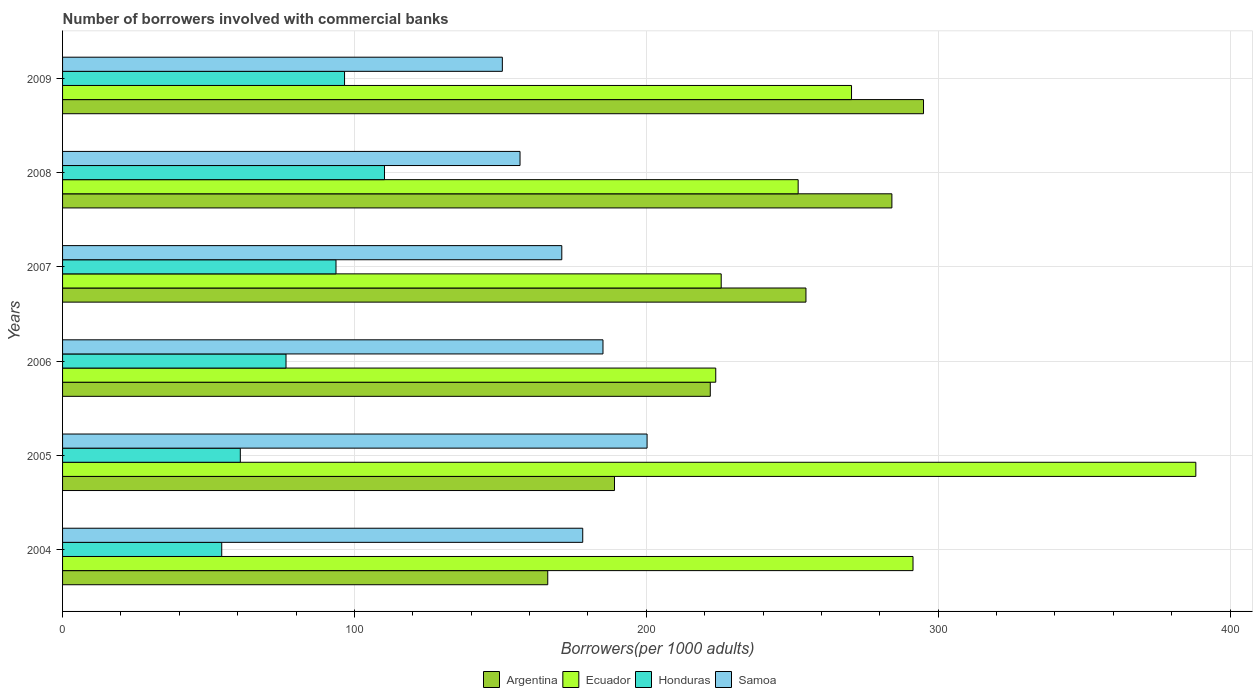Are the number of bars on each tick of the Y-axis equal?
Ensure brevity in your answer.  Yes. How many bars are there on the 5th tick from the top?
Your response must be concise. 4. How many bars are there on the 2nd tick from the bottom?
Keep it short and to the point. 4. In how many cases, is the number of bars for a given year not equal to the number of legend labels?
Offer a very short reply. 0. What is the number of borrowers involved with commercial banks in Honduras in 2006?
Give a very brief answer. 76.56. Across all years, what is the maximum number of borrowers involved with commercial banks in Ecuador?
Ensure brevity in your answer.  388.27. Across all years, what is the minimum number of borrowers involved with commercial banks in Ecuador?
Your answer should be compact. 223.79. In which year was the number of borrowers involved with commercial banks in Argentina minimum?
Ensure brevity in your answer.  2004. What is the total number of borrowers involved with commercial banks in Ecuador in the graph?
Your answer should be very brief. 1651.41. What is the difference between the number of borrowers involved with commercial banks in Honduras in 2004 and that in 2009?
Your answer should be compact. -42.07. What is the difference between the number of borrowers involved with commercial banks in Samoa in 2006 and the number of borrowers involved with commercial banks in Honduras in 2009?
Keep it short and to the point. 88.55. What is the average number of borrowers involved with commercial banks in Samoa per year?
Make the answer very short. 173.68. In the year 2005, what is the difference between the number of borrowers involved with commercial banks in Samoa and number of borrowers involved with commercial banks in Ecuador?
Make the answer very short. -188.01. In how many years, is the number of borrowers involved with commercial banks in Samoa greater than 200 ?
Offer a very short reply. 1. What is the ratio of the number of borrowers involved with commercial banks in Samoa in 2004 to that in 2009?
Your response must be concise. 1.18. What is the difference between the highest and the second highest number of borrowers involved with commercial banks in Samoa?
Your answer should be compact. 15.11. What is the difference between the highest and the lowest number of borrowers involved with commercial banks in Honduras?
Your answer should be very brief. 55.76. Is it the case that in every year, the sum of the number of borrowers involved with commercial banks in Honduras and number of borrowers involved with commercial banks in Ecuador is greater than the sum of number of borrowers involved with commercial banks in Samoa and number of borrowers involved with commercial banks in Argentina?
Provide a short and direct response. No. What does the 4th bar from the bottom in 2005 represents?
Offer a terse response. Samoa. Is it the case that in every year, the sum of the number of borrowers involved with commercial banks in Argentina and number of borrowers involved with commercial banks in Ecuador is greater than the number of borrowers involved with commercial banks in Samoa?
Give a very brief answer. Yes. How many bars are there?
Your answer should be compact. 24. Are all the bars in the graph horizontal?
Offer a terse response. Yes. How many years are there in the graph?
Your answer should be very brief. 6. What is the difference between two consecutive major ticks on the X-axis?
Your answer should be compact. 100. Does the graph contain grids?
Keep it short and to the point. Yes. How many legend labels are there?
Make the answer very short. 4. What is the title of the graph?
Provide a succinct answer. Number of borrowers involved with commercial banks. Does "Slovenia" appear as one of the legend labels in the graph?
Keep it short and to the point. No. What is the label or title of the X-axis?
Provide a succinct answer. Borrowers(per 1000 adults). What is the label or title of the Y-axis?
Offer a very short reply. Years. What is the Borrowers(per 1000 adults) in Argentina in 2004?
Provide a succinct answer. 166.23. What is the Borrowers(per 1000 adults) of Ecuador in 2004?
Your answer should be very brief. 291.37. What is the Borrowers(per 1000 adults) in Honduras in 2004?
Offer a terse response. 54.53. What is the Borrowers(per 1000 adults) of Samoa in 2004?
Give a very brief answer. 178.22. What is the Borrowers(per 1000 adults) of Argentina in 2005?
Ensure brevity in your answer.  189.09. What is the Borrowers(per 1000 adults) of Ecuador in 2005?
Offer a very short reply. 388.27. What is the Borrowers(per 1000 adults) in Honduras in 2005?
Your response must be concise. 60.9. What is the Borrowers(per 1000 adults) of Samoa in 2005?
Offer a very short reply. 200.26. What is the Borrowers(per 1000 adults) in Argentina in 2006?
Your response must be concise. 221.91. What is the Borrowers(per 1000 adults) in Ecuador in 2006?
Make the answer very short. 223.79. What is the Borrowers(per 1000 adults) in Honduras in 2006?
Your response must be concise. 76.56. What is the Borrowers(per 1000 adults) of Samoa in 2006?
Ensure brevity in your answer.  185.16. What is the Borrowers(per 1000 adults) of Argentina in 2007?
Your answer should be very brief. 254.69. What is the Borrowers(per 1000 adults) of Ecuador in 2007?
Make the answer very short. 225.65. What is the Borrowers(per 1000 adults) in Honduras in 2007?
Provide a succinct answer. 93.68. What is the Borrowers(per 1000 adults) in Samoa in 2007?
Ensure brevity in your answer.  171.04. What is the Borrowers(per 1000 adults) of Argentina in 2008?
Your response must be concise. 284.14. What is the Borrowers(per 1000 adults) in Ecuador in 2008?
Offer a terse response. 252.02. What is the Borrowers(per 1000 adults) in Honduras in 2008?
Provide a succinct answer. 110.29. What is the Borrowers(per 1000 adults) in Samoa in 2008?
Keep it short and to the point. 156.73. What is the Borrowers(per 1000 adults) in Argentina in 2009?
Provide a short and direct response. 294.97. What is the Borrowers(per 1000 adults) in Ecuador in 2009?
Keep it short and to the point. 270.31. What is the Borrowers(per 1000 adults) in Honduras in 2009?
Your answer should be compact. 96.61. What is the Borrowers(per 1000 adults) in Samoa in 2009?
Give a very brief answer. 150.68. Across all years, what is the maximum Borrowers(per 1000 adults) of Argentina?
Keep it short and to the point. 294.97. Across all years, what is the maximum Borrowers(per 1000 adults) of Ecuador?
Ensure brevity in your answer.  388.27. Across all years, what is the maximum Borrowers(per 1000 adults) of Honduras?
Provide a short and direct response. 110.29. Across all years, what is the maximum Borrowers(per 1000 adults) of Samoa?
Give a very brief answer. 200.26. Across all years, what is the minimum Borrowers(per 1000 adults) of Argentina?
Keep it short and to the point. 166.23. Across all years, what is the minimum Borrowers(per 1000 adults) in Ecuador?
Offer a very short reply. 223.79. Across all years, what is the minimum Borrowers(per 1000 adults) in Honduras?
Provide a short and direct response. 54.53. Across all years, what is the minimum Borrowers(per 1000 adults) of Samoa?
Keep it short and to the point. 150.68. What is the total Borrowers(per 1000 adults) of Argentina in the graph?
Keep it short and to the point. 1411.03. What is the total Borrowers(per 1000 adults) of Ecuador in the graph?
Give a very brief answer. 1651.41. What is the total Borrowers(per 1000 adults) in Honduras in the graph?
Your answer should be compact. 492.57. What is the total Borrowers(per 1000 adults) of Samoa in the graph?
Offer a terse response. 1042.09. What is the difference between the Borrowers(per 1000 adults) in Argentina in 2004 and that in 2005?
Offer a terse response. -22.86. What is the difference between the Borrowers(per 1000 adults) of Ecuador in 2004 and that in 2005?
Your answer should be very brief. -96.9. What is the difference between the Borrowers(per 1000 adults) in Honduras in 2004 and that in 2005?
Provide a short and direct response. -6.36. What is the difference between the Borrowers(per 1000 adults) of Samoa in 2004 and that in 2005?
Make the answer very short. -22.05. What is the difference between the Borrowers(per 1000 adults) in Argentina in 2004 and that in 2006?
Keep it short and to the point. -55.69. What is the difference between the Borrowers(per 1000 adults) of Ecuador in 2004 and that in 2006?
Offer a very short reply. 67.59. What is the difference between the Borrowers(per 1000 adults) of Honduras in 2004 and that in 2006?
Give a very brief answer. -22.02. What is the difference between the Borrowers(per 1000 adults) in Samoa in 2004 and that in 2006?
Keep it short and to the point. -6.94. What is the difference between the Borrowers(per 1000 adults) in Argentina in 2004 and that in 2007?
Your answer should be compact. -88.46. What is the difference between the Borrowers(per 1000 adults) in Ecuador in 2004 and that in 2007?
Your response must be concise. 65.72. What is the difference between the Borrowers(per 1000 adults) of Honduras in 2004 and that in 2007?
Your answer should be very brief. -39.15. What is the difference between the Borrowers(per 1000 adults) of Samoa in 2004 and that in 2007?
Keep it short and to the point. 7.17. What is the difference between the Borrowers(per 1000 adults) of Argentina in 2004 and that in 2008?
Make the answer very short. -117.91. What is the difference between the Borrowers(per 1000 adults) in Ecuador in 2004 and that in 2008?
Ensure brevity in your answer.  39.35. What is the difference between the Borrowers(per 1000 adults) of Honduras in 2004 and that in 2008?
Make the answer very short. -55.76. What is the difference between the Borrowers(per 1000 adults) of Samoa in 2004 and that in 2008?
Offer a very short reply. 21.48. What is the difference between the Borrowers(per 1000 adults) in Argentina in 2004 and that in 2009?
Ensure brevity in your answer.  -128.74. What is the difference between the Borrowers(per 1000 adults) of Ecuador in 2004 and that in 2009?
Your response must be concise. 21.06. What is the difference between the Borrowers(per 1000 adults) in Honduras in 2004 and that in 2009?
Your answer should be compact. -42.07. What is the difference between the Borrowers(per 1000 adults) of Samoa in 2004 and that in 2009?
Your answer should be compact. 27.54. What is the difference between the Borrowers(per 1000 adults) of Argentina in 2005 and that in 2006?
Make the answer very short. -32.82. What is the difference between the Borrowers(per 1000 adults) of Ecuador in 2005 and that in 2006?
Your answer should be compact. 164.48. What is the difference between the Borrowers(per 1000 adults) in Honduras in 2005 and that in 2006?
Your answer should be very brief. -15.66. What is the difference between the Borrowers(per 1000 adults) of Samoa in 2005 and that in 2006?
Provide a succinct answer. 15.11. What is the difference between the Borrowers(per 1000 adults) of Argentina in 2005 and that in 2007?
Keep it short and to the point. -65.6. What is the difference between the Borrowers(per 1000 adults) in Ecuador in 2005 and that in 2007?
Your response must be concise. 162.61. What is the difference between the Borrowers(per 1000 adults) in Honduras in 2005 and that in 2007?
Your answer should be compact. -32.79. What is the difference between the Borrowers(per 1000 adults) in Samoa in 2005 and that in 2007?
Provide a short and direct response. 29.22. What is the difference between the Borrowers(per 1000 adults) in Argentina in 2005 and that in 2008?
Offer a very short reply. -95.05. What is the difference between the Borrowers(per 1000 adults) of Ecuador in 2005 and that in 2008?
Offer a terse response. 136.25. What is the difference between the Borrowers(per 1000 adults) in Honduras in 2005 and that in 2008?
Ensure brevity in your answer.  -49.39. What is the difference between the Borrowers(per 1000 adults) of Samoa in 2005 and that in 2008?
Ensure brevity in your answer.  43.53. What is the difference between the Borrowers(per 1000 adults) in Argentina in 2005 and that in 2009?
Provide a short and direct response. -105.88. What is the difference between the Borrowers(per 1000 adults) of Ecuador in 2005 and that in 2009?
Offer a very short reply. 117.96. What is the difference between the Borrowers(per 1000 adults) of Honduras in 2005 and that in 2009?
Ensure brevity in your answer.  -35.71. What is the difference between the Borrowers(per 1000 adults) in Samoa in 2005 and that in 2009?
Keep it short and to the point. 49.59. What is the difference between the Borrowers(per 1000 adults) in Argentina in 2006 and that in 2007?
Your answer should be very brief. -32.78. What is the difference between the Borrowers(per 1000 adults) of Ecuador in 2006 and that in 2007?
Give a very brief answer. -1.87. What is the difference between the Borrowers(per 1000 adults) in Honduras in 2006 and that in 2007?
Make the answer very short. -17.13. What is the difference between the Borrowers(per 1000 adults) in Samoa in 2006 and that in 2007?
Keep it short and to the point. 14.11. What is the difference between the Borrowers(per 1000 adults) of Argentina in 2006 and that in 2008?
Offer a terse response. -62.22. What is the difference between the Borrowers(per 1000 adults) of Ecuador in 2006 and that in 2008?
Offer a terse response. -28.24. What is the difference between the Borrowers(per 1000 adults) in Honduras in 2006 and that in 2008?
Offer a terse response. -33.74. What is the difference between the Borrowers(per 1000 adults) in Samoa in 2006 and that in 2008?
Give a very brief answer. 28.42. What is the difference between the Borrowers(per 1000 adults) of Argentina in 2006 and that in 2009?
Keep it short and to the point. -73.06. What is the difference between the Borrowers(per 1000 adults) of Ecuador in 2006 and that in 2009?
Your response must be concise. -46.52. What is the difference between the Borrowers(per 1000 adults) in Honduras in 2006 and that in 2009?
Your answer should be very brief. -20.05. What is the difference between the Borrowers(per 1000 adults) in Samoa in 2006 and that in 2009?
Make the answer very short. 34.48. What is the difference between the Borrowers(per 1000 adults) of Argentina in 2007 and that in 2008?
Offer a terse response. -29.45. What is the difference between the Borrowers(per 1000 adults) in Ecuador in 2007 and that in 2008?
Offer a very short reply. -26.37. What is the difference between the Borrowers(per 1000 adults) of Honduras in 2007 and that in 2008?
Your answer should be compact. -16.61. What is the difference between the Borrowers(per 1000 adults) of Samoa in 2007 and that in 2008?
Provide a short and direct response. 14.31. What is the difference between the Borrowers(per 1000 adults) in Argentina in 2007 and that in 2009?
Your response must be concise. -40.28. What is the difference between the Borrowers(per 1000 adults) in Ecuador in 2007 and that in 2009?
Your answer should be compact. -44.66. What is the difference between the Borrowers(per 1000 adults) in Honduras in 2007 and that in 2009?
Your answer should be very brief. -2.93. What is the difference between the Borrowers(per 1000 adults) of Samoa in 2007 and that in 2009?
Give a very brief answer. 20.37. What is the difference between the Borrowers(per 1000 adults) in Argentina in 2008 and that in 2009?
Provide a succinct answer. -10.83. What is the difference between the Borrowers(per 1000 adults) in Ecuador in 2008 and that in 2009?
Your answer should be compact. -18.29. What is the difference between the Borrowers(per 1000 adults) of Honduras in 2008 and that in 2009?
Offer a terse response. 13.68. What is the difference between the Borrowers(per 1000 adults) of Samoa in 2008 and that in 2009?
Your answer should be compact. 6.06. What is the difference between the Borrowers(per 1000 adults) of Argentina in 2004 and the Borrowers(per 1000 adults) of Ecuador in 2005?
Your answer should be compact. -222.04. What is the difference between the Borrowers(per 1000 adults) in Argentina in 2004 and the Borrowers(per 1000 adults) in Honduras in 2005?
Your response must be concise. 105.33. What is the difference between the Borrowers(per 1000 adults) of Argentina in 2004 and the Borrowers(per 1000 adults) of Samoa in 2005?
Ensure brevity in your answer.  -34.04. What is the difference between the Borrowers(per 1000 adults) of Ecuador in 2004 and the Borrowers(per 1000 adults) of Honduras in 2005?
Keep it short and to the point. 230.48. What is the difference between the Borrowers(per 1000 adults) in Ecuador in 2004 and the Borrowers(per 1000 adults) in Samoa in 2005?
Give a very brief answer. 91.11. What is the difference between the Borrowers(per 1000 adults) in Honduras in 2004 and the Borrowers(per 1000 adults) in Samoa in 2005?
Offer a terse response. -145.73. What is the difference between the Borrowers(per 1000 adults) of Argentina in 2004 and the Borrowers(per 1000 adults) of Ecuador in 2006?
Offer a terse response. -57.56. What is the difference between the Borrowers(per 1000 adults) of Argentina in 2004 and the Borrowers(per 1000 adults) of Honduras in 2006?
Your answer should be compact. 89.67. What is the difference between the Borrowers(per 1000 adults) of Argentina in 2004 and the Borrowers(per 1000 adults) of Samoa in 2006?
Provide a succinct answer. -18.93. What is the difference between the Borrowers(per 1000 adults) in Ecuador in 2004 and the Borrowers(per 1000 adults) in Honduras in 2006?
Your response must be concise. 214.82. What is the difference between the Borrowers(per 1000 adults) in Ecuador in 2004 and the Borrowers(per 1000 adults) in Samoa in 2006?
Offer a very short reply. 106.22. What is the difference between the Borrowers(per 1000 adults) of Honduras in 2004 and the Borrowers(per 1000 adults) of Samoa in 2006?
Give a very brief answer. -130.62. What is the difference between the Borrowers(per 1000 adults) of Argentina in 2004 and the Borrowers(per 1000 adults) of Ecuador in 2007?
Offer a terse response. -59.43. What is the difference between the Borrowers(per 1000 adults) in Argentina in 2004 and the Borrowers(per 1000 adults) in Honduras in 2007?
Make the answer very short. 72.54. What is the difference between the Borrowers(per 1000 adults) of Argentina in 2004 and the Borrowers(per 1000 adults) of Samoa in 2007?
Give a very brief answer. -4.82. What is the difference between the Borrowers(per 1000 adults) in Ecuador in 2004 and the Borrowers(per 1000 adults) in Honduras in 2007?
Make the answer very short. 197.69. What is the difference between the Borrowers(per 1000 adults) in Ecuador in 2004 and the Borrowers(per 1000 adults) in Samoa in 2007?
Give a very brief answer. 120.33. What is the difference between the Borrowers(per 1000 adults) of Honduras in 2004 and the Borrowers(per 1000 adults) of Samoa in 2007?
Provide a succinct answer. -116.51. What is the difference between the Borrowers(per 1000 adults) of Argentina in 2004 and the Borrowers(per 1000 adults) of Ecuador in 2008?
Your answer should be very brief. -85.79. What is the difference between the Borrowers(per 1000 adults) of Argentina in 2004 and the Borrowers(per 1000 adults) of Honduras in 2008?
Your answer should be compact. 55.94. What is the difference between the Borrowers(per 1000 adults) of Argentina in 2004 and the Borrowers(per 1000 adults) of Samoa in 2008?
Your response must be concise. 9.49. What is the difference between the Borrowers(per 1000 adults) of Ecuador in 2004 and the Borrowers(per 1000 adults) of Honduras in 2008?
Offer a very short reply. 181.08. What is the difference between the Borrowers(per 1000 adults) in Ecuador in 2004 and the Borrowers(per 1000 adults) in Samoa in 2008?
Provide a succinct answer. 134.64. What is the difference between the Borrowers(per 1000 adults) of Honduras in 2004 and the Borrowers(per 1000 adults) of Samoa in 2008?
Keep it short and to the point. -102.2. What is the difference between the Borrowers(per 1000 adults) of Argentina in 2004 and the Borrowers(per 1000 adults) of Ecuador in 2009?
Ensure brevity in your answer.  -104.08. What is the difference between the Borrowers(per 1000 adults) in Argentina in 2004 and the Borrowers(per 1000 adults) in Honduras in 2009?
Provide a short and direct response. 69.62. What is the difference between the Borrowers(per 1000 adults) in Argentina in 2004 and the Borrowers(per 1000 adults) in Samoa in 2009?
Give a very brief answer. 15.55. What is the difference between the Borrowers(per 1000 adults) of Ecuador in 2004 and the Borrowers(per 1000 adults) of Honduras in 2009?
Offer a terse response. 194.76. What is the difference between the Borrowers(per 1000 adults) in Ecuador in 2004 and the Borrowers(per 1000 adults) in Samoa in 2009?
Ensure brevity in your answer.  140.7. What is the difference between the Borrowers(per 1000 adults) of Honduras in 2004 and the Borrowers(per 1000 adults) of Samoa in 2009?
Provide a short and direct response. -96.14. What is the difference between the Borrowers(per 1000 adults) of Argentina in 2005 and the Borrowers(per 1000 adults) of Ecuador in 2006?
Keep it short and to the point. -34.69. What is the difference between the Borrowers(per 1000 adults) of Argentina in 2005 and the Borrowers(per 1000 adults) of Honduras in 2006?
Your answer should be very brief. 112.54. What is the difference between the Borrowers(per 1000 adults) of Argentina in 2005 and the Borrowers(per 1000 adults) of Samoa in 2006?
Your answer should be very brief. 3.94. What is the difference between the Borrowers(per 1000 adults) in Ecuador in 2005 and the Borrowers(per 1000 adults) in Honduras in 2006?
Give a very brief answer. 311.71. What is the difference between the Borrowers(per 1000 adults) in Ecuador in 2005 and the Borrowers(per 1000 adults) in Samoa in 2006?
Give a very brief answer. 203.11. What is the difference between the Borrowers(per 1000 adults) of Honduras in 2005 and the Borrowers(per 1000 adults) of Samoa in 2006?
Your answer should be very brief. -124.26. What is the difference between the Borrowers(per 1000 adults) in Argentina in 2005 and the Borrowers(per 1000 adults) in Ecuador in 2007?
Provide a succinct answer. -36.56. What is the difference between the Borrowers(per 1000 adults) of Argentina in 2005 and the Borrowers(per 1000 adults) of Honduras in 2007?
Offer a terse response. 95.41. What is the difference between the Borrowers(per 1000 adults) in Argentina in 2005 and the Borrowers(per 1000 adults) in Samoa in 2007?
Offer a terse response. 18.05. What is the difference between the Borrowers(per 1000 adults) of Ecuador in 2005 and the Borrowers(per 1000 adults) of Honduras in 2007?
Offer a very short reply. 294.59. What is the difference between the Borrowers(per 1000 adults) in Ecuador in 2005 and the Borrowers(per 1000 adults) in Samoa in 2007?
Provide a succinct answer. 217.23. What is the difference between the Borrowers(per 1000 adults) in Honduras in 2005 and the Borrowers(per 1000 adults) in Samoa in 2007?
Offer a terse response. -110.15. What is the difference between the Borrowers(per 1000 adults) of Argentina in 2005 and the Borrowers(per 1000 adults) of Ecuador in 2008?
Give a very brief answer. -62.93. What is the difference between the Borrowers(per 1000 adults) of Argentina in 2005 and the Borrowers(per 1000 adults) of Honduras in 2008?
Provide a short and direct response. 78.8. What is the difference between the Borrowers(per 1000 adults) in Argentina in 2005 and the Borrowers(per 1000 adults) in Samoa in 2008?
Your response must be concise. 32.36. What is the difference between the Borrowers(per 1000 adults) in Ecuador in 2005 and the Borrowers(per 1000 adults) in Honduras in 2008?
Your response must be concise. 277.98. What is the difference between the Borrowers(per 1000 adults) in Ecuador in 2005 and the Borrowers(per 1000 adults) in Samoa in 2008?
Provide a short and direct response. 231.53. What is the difference between the Borrowers(per 1000 adults) in Honduras in 2005 and the Borrowers(per 1000 adults) in Samoa in 2008?
Provide a short and direct response. -95.84. What is the difference between the Borrowers(per 1000 adults) of Argentina in 2005 and the Borrowers(per 1000 adults) of Ecuador in 2009?
Keep it short and to the point. -81.22. What is the difference between the Borrowers(per 1000 adults) of Argentina in 2005 and the Borrowers(per 1000 adults) of Honduras in 2009?
Ensure brevity in your answer.  92.48. What is the difference between the Borrowers(per 1000 adults) of Argentina in 2005 and the Borrowers(per 1000 adults) of Samoa in 2009?
Your answer should be very brief. 38.42. What is the difference between the Borrowers(per 1000 adults) in Ecuador in 2005 and the Borrowers(per 1000 adults) in Honduras in 2009?
Offer a terse response. 291.66. What is the difference between the Borrowers(per 1000 adults) in Ecuador in 2005 and the Borrowers(per 1000 adults) in Samoa in 2009?
Provide a short and direct response. 237.59. What is the difference between the Borrowers(per 1000 adults) in Honduras in 2005 and the Borrowers(per 1000 adults) in Samoa in 2009?
Your answer should be compact. -89.78. What is the difference between the Borrowers(per 1000 adults) in Argentina in 2006 and the Borrowers(per 1000 adults) in Ecuador in 2007?
Make the answer very short. -3.74. What is the difference between the Borrowers(per 1000 adults) in Argentina in 2006 and the Borrowers(per 1000 adults) in Honduras in 2007?
Offer a terse response. 128.23. What is the difference between the Borrowers(per 1000 adults) of Argentina in 2006 and the Borrowers(per 1000 adults) of Samoa in 2007?
Keep it short and to the point. 50.87. What is the difference between the Borrowers(per 1000 adults) of Ecuador in 2006 and the Borrowers(per 1000 adults) of Honduras in 2007?
Your answer should be compact. 130.1. What is the difference between the Borrowers(per 1000 adults) in Ecuador in 2006 and the Borrowers(per 1000 adults) in Samoa in 2007?
Your response must be concise. 52.74. What is the difference between the Borrowers(per 1000 adults) in Honduras in 2006 and the Borrowers(per 1000 adults) in Samoa in 2007?
Give a very brief answer. -94.49. What is the difference between the Borrowers(per 1000 adults) of Argentina in 2006 and the Borrowers(per 1000 adults) of Ecuador in 2008?
Your answer should be very brief. -30.11. What is the difference between the Borrowers(per 1000 adults) in Argentina in 2006 and the Borrowers(per 1000 adults) in Honduras in 2008?
Provide a short and direct response. 111.62. What is the difference between the Borrowers(per 1000 adults) in Argentina in 2006 and the Borrowers(per 1000 adults) in Samoa in 2008?
Your answer should be very brief. 65.18. What is the difference between the Borrowers(per 1000 adults) of Ecuador in 2006 and the Borrowers(per 1000 adults) of Honduras in 2008?
Ensure brevity in your answer.  113.5. What is the difference between the Borrowers(per 1000 adults) in Ecuador in 2006 and the Borrowers(per 1000 adults) in Samoa in 2008?
Keep it short and to the point. 67.05. What is the difference between the Borrowers(per 1000 adults) of Honduras in 2006 and the Borrowers(per 1000 adults) of Samoa in 2008?
Provide a succinct answer. -80.18. What is the difference between the Borrowers(per 1000 adults) of Argentina in 2006 and the Borrowers(per 1000 adults) of Ecuador in 2009?
Ensure brevity in your answer.  -48.4. What is the difference between the Borrowers(per 1000 adults) in Argentina in 2006 and the Borrowers(per 1000 adults) in Honduras in 2009?
Ensure brevity in your answer.  125.3. What is the difference between the Borrowers(per 1000 adults) in Argentina in 2006 and the Borrowers(per 1000 adults) in Samoa in 2009?
Make the answer very short. 71.24. What is the difference between the Borrowers(per 1000 adults) of Ecuador in 2006 and the Borrowers(per 1000 adults) of Honduras in 2009?
Provide a short and direct response. 127.18. What is the difference between the Borrowers(per 1000 adults) of Ecuador in 2006 and the Borrowers(per 1000 adults) of Samoa in 2009?
Keep it short and to the point. 73.11. What is the difference between the Borrowers(per 1000 adults) of Honduras in 2006 and the Borrowers(per 1000 adults) of Samoa in 2009?
Provide a short and direct response. -74.12. What is the difference between the Borrowers(per 1000 adults) of Argentina in 2007 and the Borrowers(per 1000 adults) of Ecuador in 2008?
Your answer should be very brief. 2.67. What is the difference between the Borrowers(per 1000 adults) of Argentina in 2007 and the Borrowers(per 1000 adults) of Honduras in 2008?
Your response must be concise. 144.4. What is the difference between the Borrowers(per 1000 adults) of Argentina in 2007 and the Borrowers(per 1000 adults) of Samoa in 2008?
Keep it short and to the point. 97.96. What is the difference between the Borrowers(per 1000 adults) of Ecuador in 2007 and the Borrowers(per 1000 adults) of Honduras in 2008?
Offer a very short reply. 115.36. What is the difference between the Borrowers(per 1000 adults) in Ecuador in 2007 and the Borrowers(per 1000 adults) in Samoa in 2008?
Offer a very short reply. 68.92. What is the difference between the Borrowers(per 1000 adults) in Honduras in 2007 and the Borrowers(per 1000 adults) in Samoa in 2008?
Keep it short and to the point. -63.05. What is the difference between the Borrowers(per 1000 adults) in Argentina in 2007 and the Borrowers(per 1000 adults) in Ecuador in 2009?
Offer a very short reply. -15.62. What is the difference between the Borrowers(per 1000 adults) in Argentina in 2007 and the Borrowers(per 1000 adults) in Honduras in 2009?
Make the answer very short. 158.08. What is the difference between the Borrowers(per 1000 adults) in Argentina in 2007 and the Borrowers(per 1000 adults) in Samoa in 2009?
Make the answer very short. 104.02. What is the difference between the Borrowers(per 1000 adults) in Ecuador in 2007 and the Borrowers(per 1000 adults) in Honduras in 2009?
Provide a succinct answer. 129.04. What is the difference between the Borrowers(per 1000 adults) in Ecuador in 2007 and the Borrowers(per 1000 adults) in Samoa in 2009?
Your answer should be compact. 74.98. What is the difference between the Borrowers(per 1000 adults) of Honduras in 2007 and the Borrowers(per 1000 adults) of Samoa in 2009?
Offer a terse response. -56.99. What is the difference between the Borrowers(per 1000 adults) in Argentina in 2008 and the Borrowers(per 1000 adults) in Ecuador in 2009?
Offer a terse response. 13.83. What is the difference between the Borrowers(per 1000 adults) of Argentina in 2008 and the Borrowers(per 1000 adults) of Honduras in 2009?
Your answer should be very brief. 187.53. What is the difference between the Borrowers(per 1000 adults) in Argentina in 2008 and the Borrowers(per 1000 adults) in Samoa in 2009?
Provide a short and direct response. 133.46. What is the difference between the Borrowers(per 1000 adults) of Ecuador in 2008 and the Borrowers(per 1000 adults) of Honduras in 2009?
Your response must be concise. 155.41. What is the difference between the Borrowers(per 1000 adults) of Ecuador in 2008 and the Borrowers(per 1000 adults) of Samoa in 2009?
Offer a terse response. 101.35. What is the difference between the Borrowers(per 1000 adults) of Honduras in 2008 and the Borrowers(per 1000 adults) of Samoa in 2009?
Provide a short and direct response. -40.38. What is the average Borrowers(per 1000 adults) of Argentina per year?
Provide a succinct answer. 235.17. What is the average Borrowers(per 1000 adults) in Ecuador per year?
Make the answer very short. 275.24. What is the average Borrowers(per 1000 adults) of Honduras per year?
Your answer should be very brief. 82.1. What is the average Borrowers(per 1000 adults) of Samoa per year?
Give a very brief answer. 173.68. In the year 2004, what is the difference between the Borrowers(per 1000 adults) in Argentina and Borrowers(per 1000 adults) in Ecuador?
Ensure brevity in your answer.  -125.15. In the year 2004, what is the difference between the Borrowers(per 1000 adults) in Argentina and Borrowers(per 1000 adults) in Honduras?
Provide a succinct answer. 111.69. In the year 2004, what is the difference between the Borrowers(per 1000 adults) of Argentina and Borrowers(per 1000 adults) of Samoa?
Offer a terse response. -11.99. In the year 2004, what is the difference between the Borrowers(per 1000 adults) in Ecuador and Borrowers(per 1000 adults) in Honduras?
Make the answer very short. 236.84. In the year 2004, what is the difference between the Borrowers(per 1000 adults) in Ecuador and Borrowers(per 1000 adults) in Samoa?
Keep it short and to the point. 113.16. In the year 2004, what is the difference between the Borrowers(per 1000 adults) in Honduras and Borrowers(per 1000 adults) in Samoa?
Make the answer very short. -123.68. In the year 2005, what is the difference between the Borrowers(per 1000 adults) in Argentina and Borrowers(per 1000 adults) in Ecuador?
Give a very brief answer. -199.18. In the year 2005, what is the difference between the Borrowers(per 1000 adults) of Argentina and Borrowers(per 1000 adults) of Honduras?
Offer a terse response. 128.19. In the year 2005, what is the difference between the Borrowers(per 1000 adults) of Argentina and Borrowers(per 1000 adults) of Samoa?
Offer a very short reply. -11.17. In the year 2005, what is the difference between the Borrowers(per 1000 adults) in Ecuador and Borrowers(per 1000 adults) in Honduras?
Provide a short and direct response. 327.37. In the year 2005, what is the difference between the Borrowers(per 1000 adults) of Ecuador and Borrowers(per 1000 adults) of Samoa?
Provide a short and direct response. 188.01. In the year 2005, what is the difference between the Borrowers(per 1000 adults) in Honduras and Borrowers(per 1000 adults) in Samoa?
Offer a very short reply. -139.37. In the year 2006, what is the difference between the Borrowers(per 1000 adults) in Argentina and Borrowers(per 1000 adults) in Ecuador?
Make the answer very short. -1.87. In the year 2006, what is the difference between the Borrowers(per 1000 adults) of Argentina and Borrowers(per 1000 adults) of Honduras?
Provide a short and direct response. 145.36. In the year 2006, what is the difference between the Borrowers(per 1000 adults) in Argentina and Borrowers(per 1000 adults) in Samoa?
Your response must be concise. 36.76. In the year 2006, what is the difference between the Borrowers(per 1000 adults) of Ecuador and Borrowers(per 1000 adults) of Honduras?
Give a very brief answer. 147.23. In the year 2006, what is the difference between the Borrowers(per 1000 adults) in Ecuador and Borrowers(per 1000 adults) in Samoa?
Your answer should be very brief. 38.63. In the year 2006, what is the difference between the Borrowers(per 1000 adults) in Honduras and Borrowers(per 1000 adults) in Samoa?
Your response must be concise. -108.6. In the year 2007, what is the difference between the Borrowers(per 1000 adults) in Argentina and Borrowers(per 1000 adults) in Ecuador?
Your answer should be compact. 29.04. In the year 2007, what is the difference between the Borrowers(per 1000 adults) in Argentina and Borrowers(per 1000 adults) in Honduras?
Provide a succinct answer. 161.01. In the year 2007, what is the difference between the Borrowers(per 1000 adults) in Argentina and Borrowers(per 1000 adults) in Samoa?
Your answer should be very brief. 83.65. In the year 2007, what is the difference between the Borrowers(per 1000 adults) of Ecuador and Borrowers(per 1000 adults) of Honduras?
Offer a terse response. 131.97. In the year 2007, what is the difference between the Borrowers(per 1000 adults) in Ecuador and Borrowers(per 1000 adults) in Samoa?
Offer a very short reply. 54.61. In the year 2007, what is the difference between the Borrowers(per 1000 adults) of Honduras and Borrowers(per 1000 adults) of Samoa?
Ensure brevity in your answer.  -77.36. In the year 2008, what is the difference between the Borrowers(per 1000 adults) in Argentina and Borrowers(per 1000 adults) in Ecuador?
Your response must be concise. 32.12. In the year 2008, what is the difference between the Borrowers(per 1000 adults) in Argentina and Borrowers(per 1000 adults) in Honduras?
Your answer should be very brief. 173.85. In the year 2008, what is the difference between the Borrowers(per 1000 adults) of Argentina and Borrowers(per 1000 adults) of Samoa?
Your response must be concise. 127.4. In the year 2008, what is the difference between the Borrowers(per 1000 adults) of Ecuador and Borrowers(per 1000 adults) of Honduras?
Offer a terse response. 141.73. In the year 2008, what is the difference between the Borrowers(per 1000 adults) in Ecuador and Borrowers(per 1000 adults) in Samoa?
Provide a short and direct response. 95.29. In the year 2008, what is the difference between the Borrowers(per 1000 adults) of Honduras and Borrowers(per 1000 adults) of Samoa?
Ensure brevity in your answer.  -46.44. In the year 2009, what is the difference between the Borrowers(per 1000 adults) of Argentina and Borrowers(per 1000 adults) of Ecuador?
Offer a terse response. 24.66. In the year 2009, what is the difference between the Borrowers(per 1000 adults) of Argentina and Borrowers(per 1000 adults) of Honduras?
Your answer should be very brief. 198.36. In the year 2009, what is the difference between the Borrowers(per 1000 adults) in Argentina and Borrowers(per 1000 adults) in Samoa?
Offer a very short reply. 144.3. In the year 2009, what is the difference between the Borrowers(per 1000 adults) in Ecuador and Borrowers(per 1000 adults) in Honduras?
Your answer should be compact. 173.7. In the year 2009, what is the difference between the Borrowers(per 1000 adults) of Ecuador and Borrowers(per 1000 adults) of Samoa?
Offer a very short reply. 119.63. In the year 2009, what is the difference between the Borrowers(per 1000 adults) in Honduras and Borrowers(per 1000 adults) in Samoa?
Your answer should be very brief. -54.07. What is the ratio of the Borrowers(per 1000 adults) of Argentina in 2004 to that in 2005?
Ensure brevity in your answer.  0.88. What is the ratio of the Borrowers(per 1000 adults) in Ecuador in 2004 to that in 2005?
Your answer should be compact. 0.75. What is the ratio of the Borrowers(per 1000 adults) in Honduras in 2004 to that in 2005?
Make the answer very short. 0.9. What is the ratio of the Borrowers(per 1000 adults) in Samoa in 2004 to that in 2005?
Your response must be concise. 0.89. What is the ratio of the Borrowers(per 1000 adults) of Argentina in 2004 to that in 2006?
Provide a short and direct response. 0.75. What is the ratio of the Borrowers(per 1000 adults) in Ecuador in 2004 to that in 2006?
Make the answer very short. 1.3. What is the ratio of the Borrowers(per 1000 adults) of Honduras in 2004 to that in 2006?
Give a very brief answer. 0.71. What is the ratio of the Borrowers(per 1000 adults) of Samoa in 2004 to that in 2006?
Your response must be concise. 0.96. What is the ratio of the Borrowers(per 1000 adults) in Argentina in 2004 to that in 2007?
Make the answer very short. 0.65. What is the ratio of the Borrowers(per 1000 adults) of Ecuador in 2004 to that in 2007?
Offer a very short reply. 1.29. What is the ratio of the Borrowers(per 1000 adults) of Honduras in 2004 to that in 2007?
Ensure brevity in your answer.  0.58. What is the ratio of the Borrowers(per 1000 adults) in Samoa in 2004 to that in 2007?
Provide a short and direct response. 1.04. What is the ratio of the Borrowers(per 1000 adults) of Argentina in 2004 to that in 2008?
Make the answer very short. 0.58. What is the ratio of the Borrowers(per 1000 adults) of Ecuador in 2004 to that in 2008?
Make the answer very short. 1.16. What is the ratio of the Borrowers(per 1000 adults) in Honduras in 2004 to that in 2008?
Give a very brief answer. 0.49. What is the ratio of the Borrowers(per 1000 adults) of Samoa in 2004 to that in 2008?
Your response must be concise. 1.14. What is the ratio of the Borrowers(per 1000 adults) in Argentina in 2004 to that in 2009?
Provide a succinct answer. 0.56. What is the ratio of the Borrowers(per 1000 adults) of Ecuador in 2004 to that in 2009?
Your answer should be very brief. 1.08. What is the ratio of the Borrowers(per 1000 adults) in Honduras in 2004 to that in 2009?
Offer a very short reply. 0.56. What is the ratio of the Borrowers(per 1000 adults) in Samoa in 2004 to that in 2009?
Offer a terse response. 1.18. What is the ratio of the Borrowers(per 1000 adults) in Argentina in 2005 to that in 2006?
Your answer should be very brief. 0.85. What is the ratio of the Borrowers(per 1000 adults) in Ecuador in 2005 to that in 2006?
Offer a very short reply. 1.74. What is the ratio of the Borrowers(per 1000 adults) in Honduras in 2005 to that in 2006?
Keep it short and to the point. 0.8. What is the ratio of the Borrowers(per 1000 adults) in Samoa in 2005 to that in 2006?
Offer a terse response. 1.08. What is the ratio of the Borrowers(per 1000 adults) in Argentina in 2005 to that in 2007?
Your answer should be compact. 0.74. What is the ratio of the Borrowers(per 1000 adults) in Ecuador in 2005 to that in 2007?
Make the answer very short. 1.72. What is the ratio of the Borrowers(per 1000 adults) of Honduras in 2005 to that in 2007?
Provide a short and direct response. 0.65. What is the ratio of the Borrowers(per 1000 adults) in Samoa in 2005 to that in 2007?
Your answer should be compact. 1.17. What is the ratio of the Borrowers(per 1000 adults) of Argentina in 2005 to that in 2008?
Make the answer very short. 0.67. What is the ratio of the Borrowers(per 1000 adults) of Ecuador in 2005 to that in 2008?
Your answer should be very brief. 1.54. What is the ratio of the Borrowers(per 1000 adults) in Honduras in 2005 to that in 2008?
Your response must be concise. 0.55. What is the ratio of the Borrowers(per 1000 adults) of Samoa in 2005 to that in 2008?
Your response must be concise. 1.28. What is the ratio of the Borrowers(per 1000 adults) in Argentina in 2005 to that in 2009?
Keep it short and to the point. 0.64. What is the ratio of the Borrowers(per 1000 adults) in Ecuador in 2005 to that in 2009?
Your answer should be compact. 1.44. What is the ratio of the Borrowers(per 1000 adults) in Honduras in 2005 to that in 2009?
Your response must be concise. 0.63. What is the ratio of the Borrowers(per 1000 adults) in Samoa in 2005 to that in 2009?
Make the answer very short. 1.33. What is the ratio of the Borrowers(per 1000 adults) of Argentina in 2006 to that in 2007?
Your answer should be very brief. 0.87. What is the ratio of the Borrowers(per 1000 adults) of Ecuador in 2006 to that in 2007?
Your answer should be compact. 0.99. What is the ratio of the Borrowers(per 1000 adults) in Honduras in 2006 to that in 2007?
Give a very brief answer. 0.82. What is the ratio of the Borrowers(per 1000 adults) in Samoa in 2006 to that in 2007?
Ensure brevity in your answer.  1.08. What is the ratio of the Borrowers(per 1000 adults) in Argentina in 2006 to that in 2008?
Offer a very short reply. 0.78. What is the ratio of the Borrowers(per 1000 adults) of Ecuador in 2006 to that in 2008?
Provide a short and direct response. 0.89. What is the ratio of the Borrowers(per 1000 adults) of Honduras in 2006 to that in 2008?
Make the answer very short. 0.69. What is the ratio of the Borrowers(per 1000 adults) in Samoa in 2006 to that in 2008?
Your answer should be compact. 1.18. What is the ratio of the Borrowers(per 1000 adults) in Argentina in 2006 to that in 2009?
Ensure brevity in your answer.  0.75. What is the ratio of the Borrowers(per 1000 adults) in Ecuador in 2006 to that in 2009?
Provide a succinct answer. 0.83. What is the ratio of the Borrowers(per 1000 adults) in Honduras in 2006 to that in 2009?
Offer a terse response. 0.79. What is the ratio of the Borrowers(per 1000 adults) in Samoa in 2006 to that in 2009?
Provide a short and direct response. 1.23. What is the ratio of the Borrowers(per 1000 adults) of Argentina in 2007 to that in 2008?
Provide a short and direct response. 0.9. What is the ratio of the Borrowers(per 1000 adults) of Ecuador in 2007 to that in 2008?
Offer a terse response. 0.9. What is the ratio of the Borrowers(per 1000 adults) of Honduras in 2007 to that in 2008?
Provide a short and direct response. 0.85. What is the ratio of the Borrowers(per 1000 adults) in Samoa in 2007 to that in 2008?
Your response must be concise. 1.09. What is the ratio of the Borrowers(per 1000 adults) in Argentina in 2007 to that in 2009?
Keep it short and to the point. 0.86. What is the ratio of the Borrowers(per 1000 adults) of Ecuador in 2007 to that in 2009?
Provide a short and direct response. 0.83. What is the ratio of the Borrowers(per 1000 adults) in Honduras in 2007 to that in 2009?
Provide a short and direct response. 0.97. What is the ratio of the Borrowers(per 1000 adults) in Samoa in 2007 to that in 2009?
Your answer should be very brief. 1.14. What is the ratio of the Borrowers(per 1000 adults) of Argentina in 2008 to that in 2009?
Your response must be concise. 0.96. What is the ratio of the Borrowers(per 1000 adults) of Ecuador in 2008 to that in 2009?
Your response must be concise. 0.93. What is the ratio of the Borrowers(per 1000 adults) in Honduras in 2008 to that in 2009?
Keep it short and to the point. 1.14. What is the ratio of the Borrowers(per 1000 adults) of Samoa in 2008 to that in 2009?
Offer a very short reply. 1.04. What is the difference between the highest and the second highest Borrowers(per 1000 adults) of Argentina?
Provide a short and direct response. 10.83. What is the difference between the highest and the second highest Borrowers(per 1000 adults) of Ecuador?
Give a very brief answer. 96.9. What is the difference between the highest and the second highest Borrowers(per 1000 adults) in Honduras?
Offer a very short reply. 13.68. What is the difference between the highest and the second highest Borrowers(per 1000 adults) in Samoa?
Your answer should be compact. 15.11. What is the difference between the highest and the lowest Borrowers(per 1000 adults) in Argentina?
Provide a short and direct response. 128.74. What is the difference between the highest and the lowest Borrowers(per 1000 adults) in Ecuador?
Provide a short and direct response. 164.48. What is the difference between the highest and the lowest Borrowers(per 1000 adults) of Honduras?
Give a very brief answer. 55.76. What is the difference between the highest and the lowest Borrowers(per 1000 adults) of Samoa?
Your response must be concise. 49.59. 